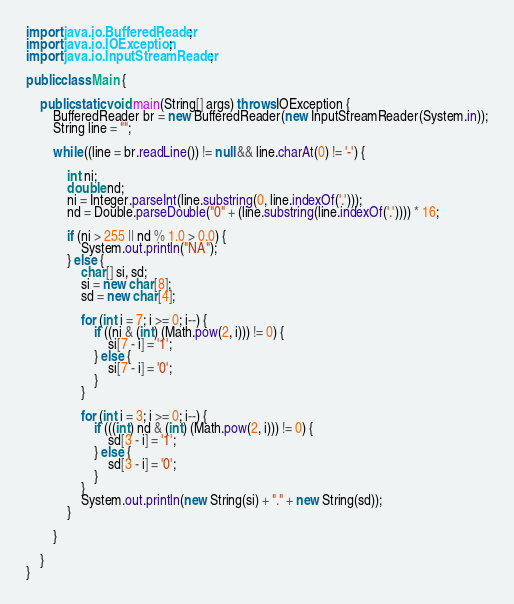Convert code to text. <code><loc_0><loc_0><loc_500><loc_500><_Java_>import java.io.BufferedReader;
import java.io.IOException;
import java.io.InputStreamReader;

public class Main {

	public static void main(String[] args) throws IOException {
		BufferedReader br = new BufferedReader(new InputStreamReader(System.in));
		String line = "";

		while ((line = br.readLine()) != null && line.charAt(0) != '-') {

			int ni;
			double nd;
			ni = Integer.parseInt(line.substring(0, line.indexOf('.')));
			nd = Double.parseDouble("0" + (line.substring(line.indexOf('.')))) * 16;

			if (ni > 255 || nd % 1.0 > 0.0) {
				System.out.println("NA");
			} else {
				char[] si, sd;
				si = new char[8];
				sd = new char[4];

				for (int i = 7; i >= 0; i--) {
					if ((ni & (int) (Math.pow(2, i))) != 0) {
						si[7 - i] = '1';
					} else {
						si[7 - i] = '0';
					}
				}

				for (int i = 3; i >= 0; i--) {
					if (((int) nd & (int) (Math.pow(2, i))) != 0) {
						sd[3 - i] = '1';
					} else {
						sd[3 - i] = '0';
					}
				}
				System.out.println(new String(si) + "." + new String(sd));
			}

		}

	}
}</code> 